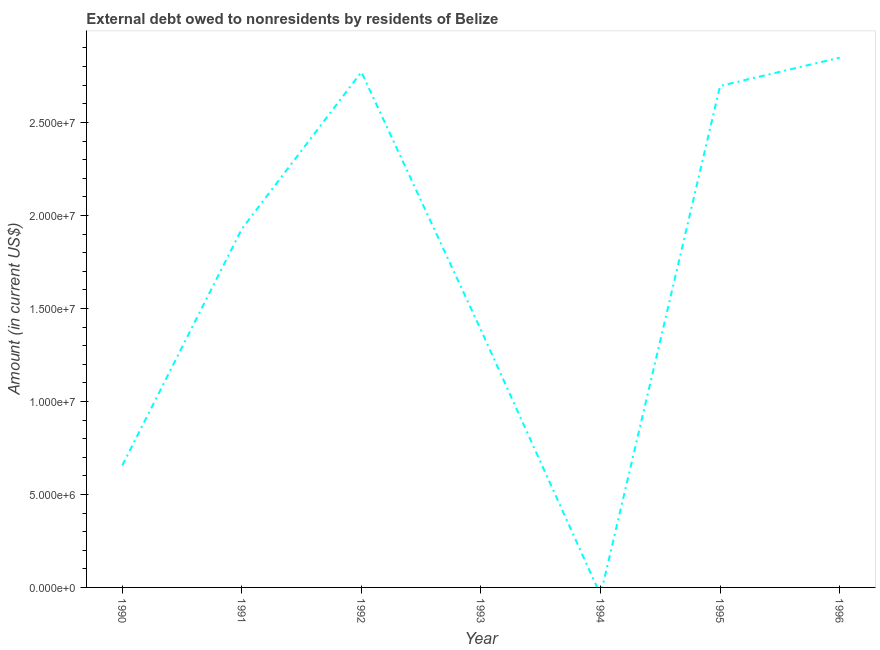What is the debt in 1996?
Your answer should be very brief. 2.85e+07. Across all years, what is the maximum debt?
Keep it short and to the point. 2.85e+07. What is the sum of the debt?
Give a very brief answer. 1.23e+08. What is the difference between the debt in 1990 and 1996?
Your answer should be very brief. -2.19e+07. What is the average debt per year?
Your answer should be very brief. 1.75e+07. What is the median debt?
Ensure brevity in your answer.  1.93e+07. In how many years, is the debt greater than 14000000 US$?
Offer a terse response. 4. What is the ratio of the debt in 1992 to that in 1995?
Provide a succinct answer. 1.03. What is the difference between the highest and the second highest debt?
Provide a short and direct response. 7.69e+05. Is the sum of the debt in 1990 and 1993 greater than the maximum debt across all years?
Ensure brevity in your answer.  No. What is the difference between the highest and the lowest debt?
Give a very brief answer. 2.85e+07. Are the values on the major ticks of Y-axis written in scientific E-notation?
Provide a succinct answer. Yes. Does the graph contain any zero values?
Offer a very short reply. Yes. What is the title of the graph?
Your answer should be very brief. External debt owed to nonresidents by residents of Belize. What is the Amount (in current US$) of 1990?
Your answer should be very brief. 6.56e+06. What is the Amount (in current US$) of 1991?
Provide a short and direct response. 1.93e+07. What is the Amount (in current US$) in 1992?
Ensure brevity in your answer.  2.77e+07. What is the Amount (in current US$) of 1993?
Give a very brief answer. 1.38e+07. What is the Amount (in current US$) of 1994?
Your answer should be very brief. 0. What is the Amount (in current US$) in 1995?
Give a very brief answer. 2.70e+07. What is the Amount (in current US$) of 1996?
Give a very brief answer. 2.85e+07. What is the difference between the Amount (in current US$) in 1990 and 1991?
Ensure brevity in your answer.  -1.27e+07. What is the difference between the Amount (in current US$) in 1990 and 1992?
Offer a terse response. -2.11e+07. What is the difference between the Amount (in current US$) in 1990 and 1993?
Ensure brevity in your answer.  -7.28e+06. What is the difference between the Amount (in current US$) in 1990 and 1995?
Your response must be concise. -2.04e+07. What is the difference between the Amount (in current US$) in 1990 and 1996?
Your response must be concise. -2.19e+07. What is the difference between the Amount (in current US$) in 1991 and 1992?
Provide a short and direct response. -8.43e+06. What is the difference between the Amount (in current US$) in 1991 and 1993?
Your answer should be compact. 5.44e+06. What is the difference between the Amount (in current US$) in 1991 and 1995?
Give a very brief answer. -7.68e+06. What is the difference between the Amount (in current US$) in 1991 and 1996?
Give a very brief answer. -9.20e+06. What is the difference between the Amount (in current US$) in 1992 and 1993?
Your answer should be compact. 1.39e+07. What is the difference between the Amount (in current US$) in 1992 and 1995?
Your answer should be compact. 7.50e+05. What is the difference between the Amount (in current US$) in 1992 and 1996?
Your answer should be very brief. -7.69e+05. What is the difference between the Amount (in current US$) in 1993 and 1995?
Offer a terse response. -1.31e+07. What is the difference between the Amount (in current US$) in 1993 and 1996?
Provide a succinct answer. -1.46e+07. What is the difference between the Amount (in current US$) in 1995 and 1996?
Ensure brevity in your answer.  -1.52e+06. What is the ratio of the Amount (in current US$) in 1990 to that in 1991?
Your response must be concise. 0.34. What is the ratio of the Amount (in current US$) in 1990 to that in 1992?
Your response must be concise. 0.24. What is the ratio of the Amount (in current US$) in 1990 to that in 1993?
Give a very brief answer. 0.47. What is the ratio of the Amount (in current US$) in 1990 to that in 1995?
Provide a short and direct response. 0.24. What is the ratio of the Amount (in current US$) in 1990 to that in 1996?
Make the answer very short. 0.23. What is the ratio of the Amount (in current US$) in 1991 to that in 1992?
Your answer should be compact. 0.7. What is the ratio of the Amount (in current US$) in 1991 to that in 1993?
Your answer should be very brief. 1.39. What is the ratio of the Amount (in current US$) in 1991 to that in 1995?
Provide a short and direct response. 0.71. What is the ratio of the Amount (in current US$) in 1991 to that in 1996?
Ensure brevity in your answer.  0.68. What is the ratio of the Amount (in current US$) in 1992 to that in 1993?
Keep it short and to the point. 2. What is the ratio of the Amount (in current US$) in 1992 to that in 1995?
Keep it short and to the point. 1.03. What is the ratio of the Amount (in current US$) in 1993 to that in 1995?
Offer a terse response. 0.51. What is the ratio of the Amount (in current US$) in 1993 to that in 1996?
Ensure brevity in your answer.  0.49. What is the ratio of the Amount (in current US$) in 1995 to that in 1996?
Ensure brevity in your answer.  0.95. 